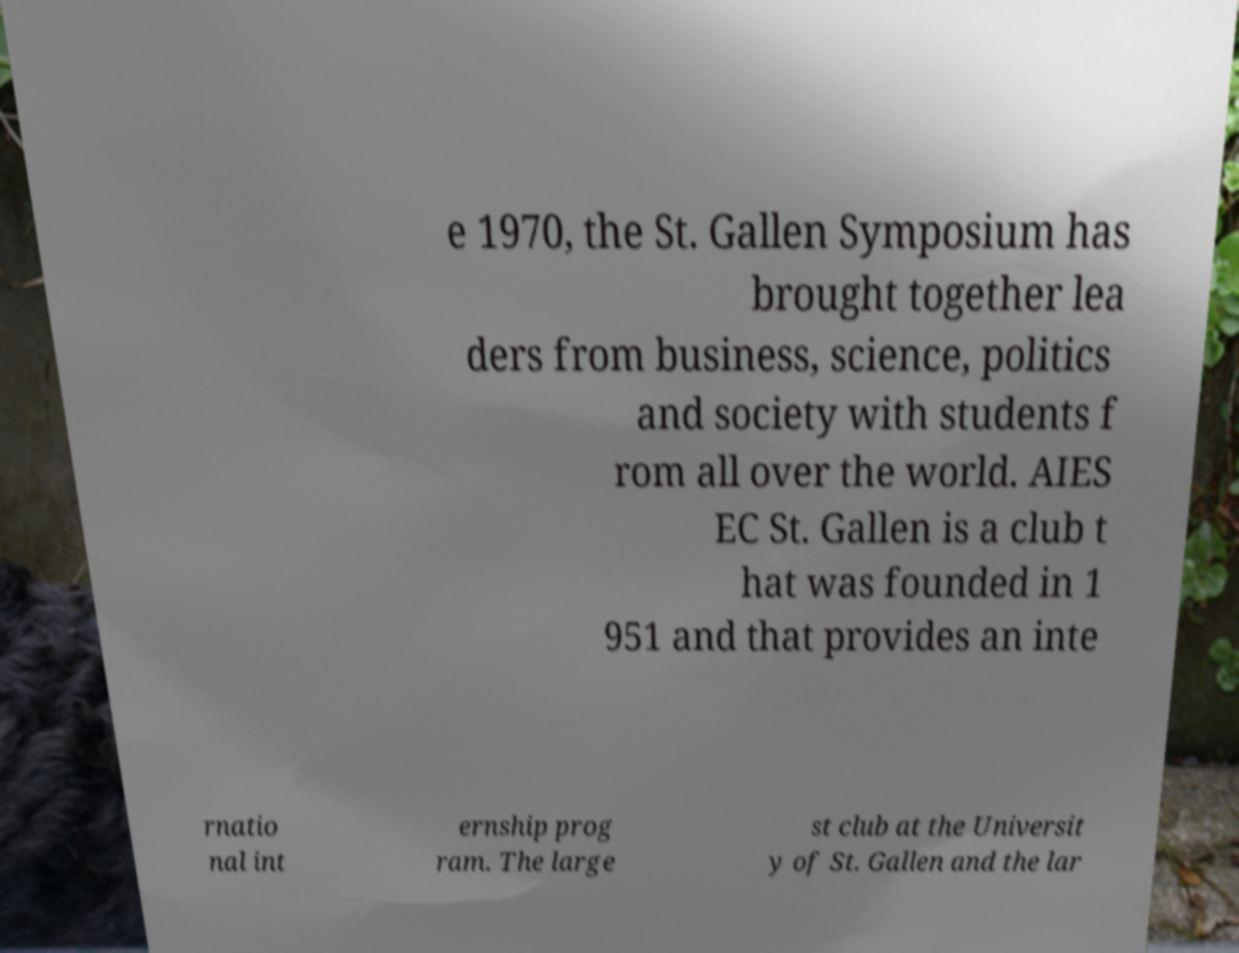There's text embedded in this image that I need extracted. Can you transcribe it verbatim? e 1970, the St. Gallen Symposium has brought together lea ders from business, science, politics and society with students f rom all over the world. AIES EC St. Gallen is a club t hat was founded in 1 951 and that provides an inte rnatio nal int ernship prog ram. The large st club at the Universit y of St. Gallen and the lar 